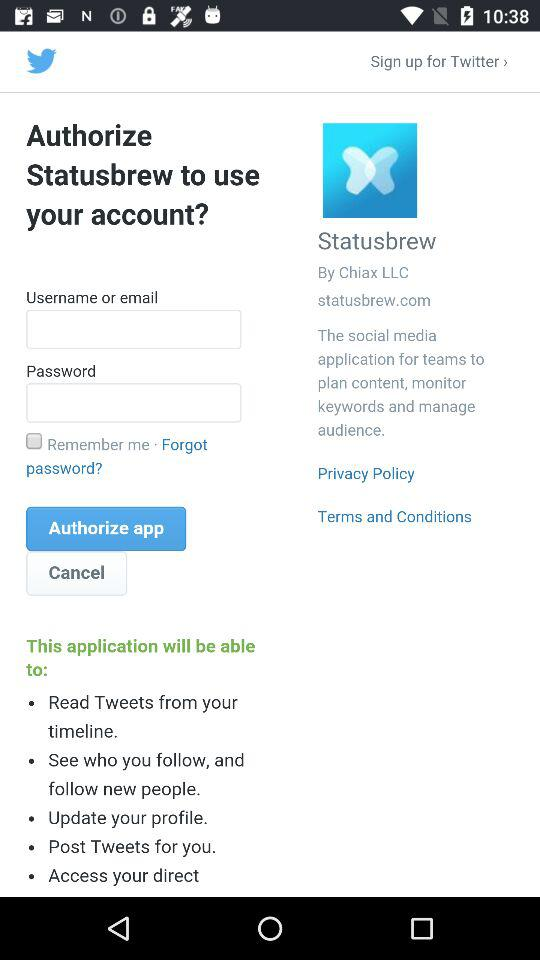What is the status of "Remember me"? The status of "Remember me" is "off". 